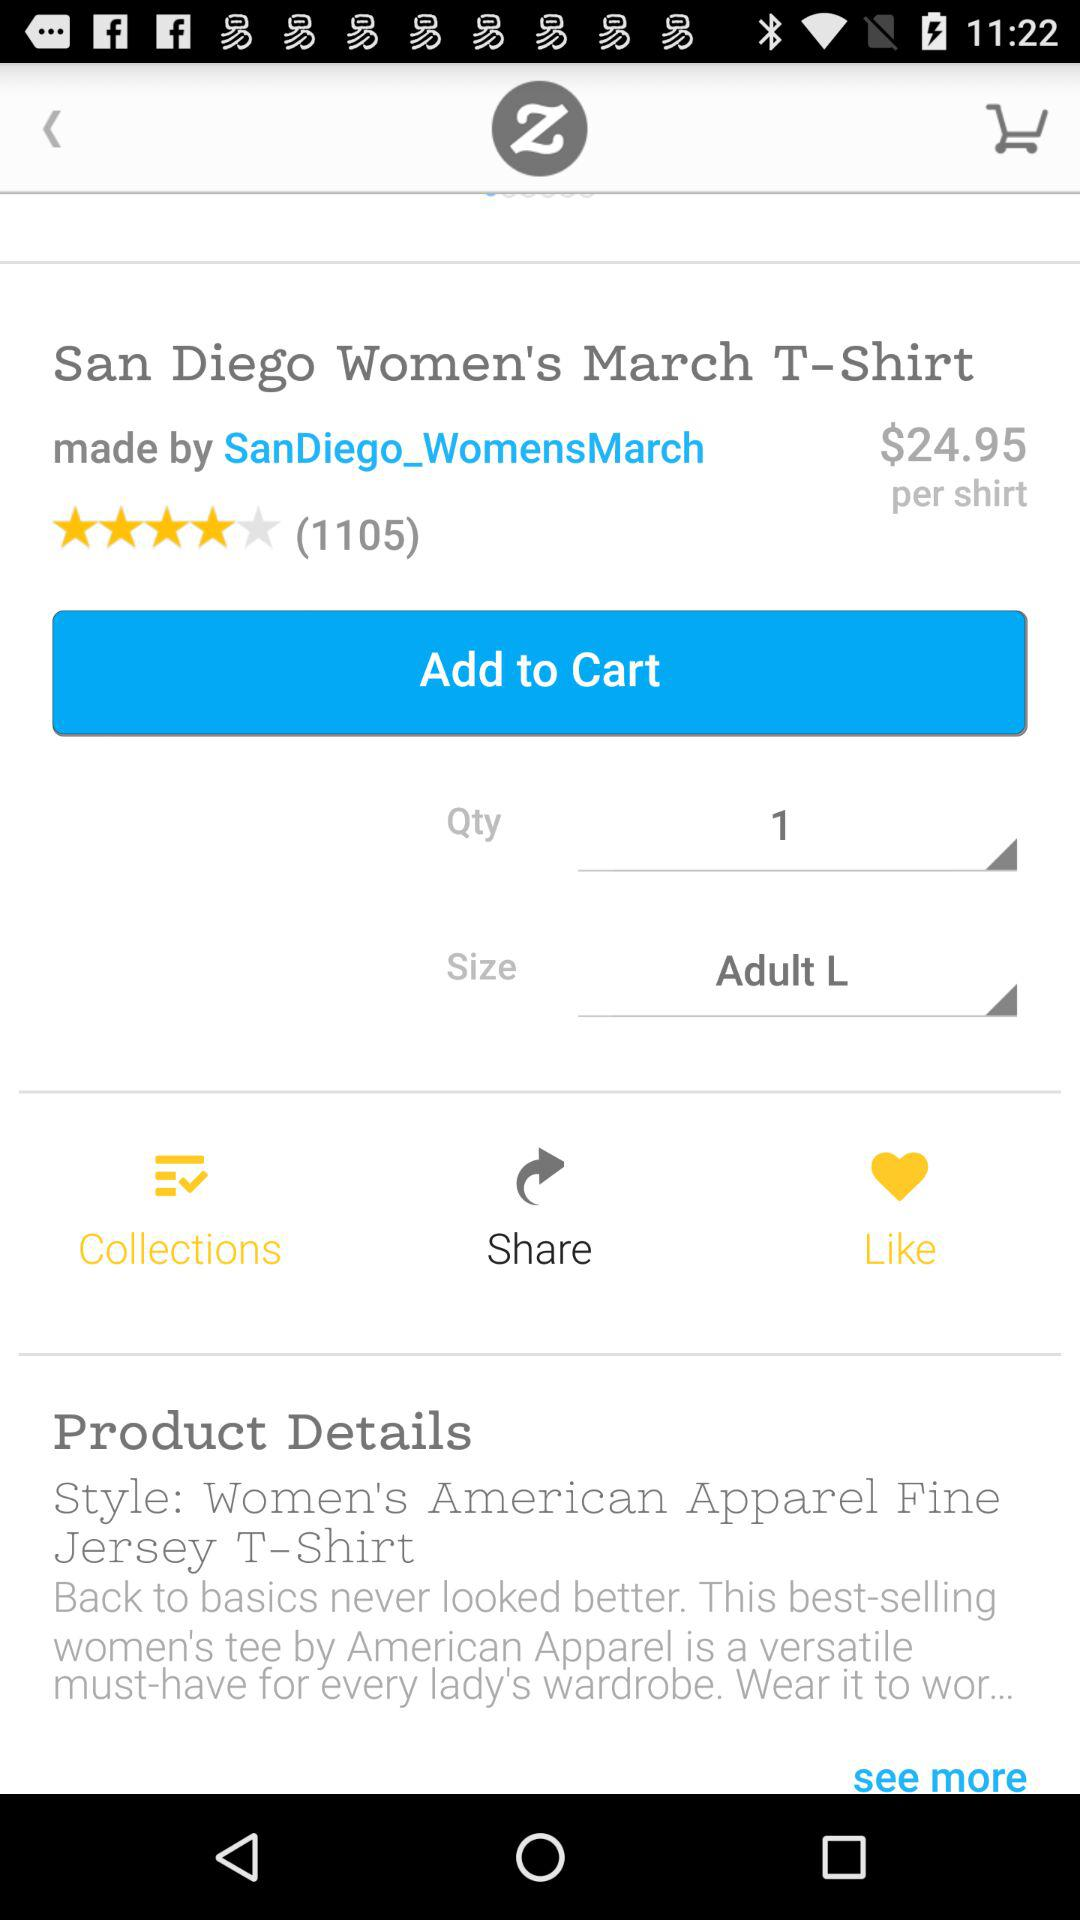What size was selected? The selected size was "Adult L". 